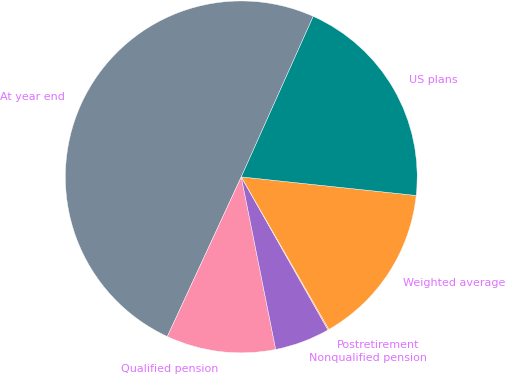Convert chart. <chart><loc_0><loc_0><loc_500><loc_500><pie_chart><fcel>At year end<fcel>Qualified pension<fcel>Nonqualified pension<fcel>Postretirement<fcel>Weighted average<fcel>US plans<nl><fcel>49.81%<fcel>10.04%<fcel>5.07%<fcel>0.1%<fcel>15.01%<fcel>19.98%<nl></chart> 